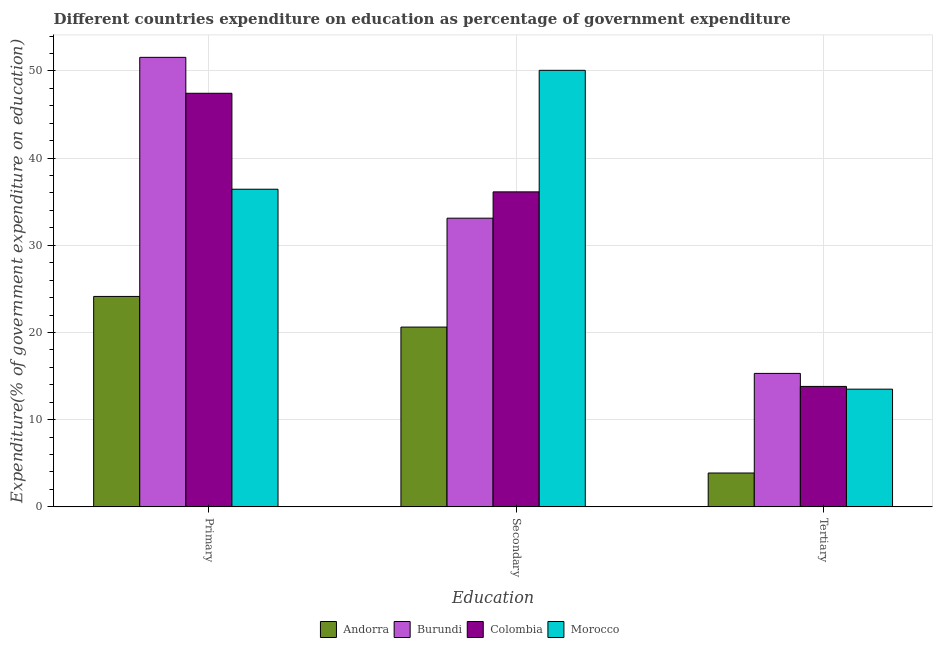How many different coloured bars are there?
Your answer should be very brief. 4. How many groups of bars are there?
Your answer should be very brief. 3. Are the number of bars per tick equal to the number of legend labels?
Make the answer very short. Yes. What is the label of the 2nd group of bars from the left?
Make the answer very short. Secondary. What is the expenditure on secondary education in Burundi?
Your response must be concise. 33.11. Across all countries, what is the maximum expenditure on secondary education?
Offer a very short reply. 50.07. Across all countries, what is the minimum expenditure on primary education?
Offer a very short reply. 24.14. In which country was the expenditure on secondary education maximum?
Make the answer very short. Morocco. In which country was the expenditure on primary education minimum?
Ensure brevity in your answer.  Andorra. What is the total expenditure on primary education in the graph?
Your answer should be compact. 159.56. What is the difference between the expenditure on tertiary education in Andorra and that in Colombia?
Your answer should be compact. -9.93. What is the difference between the expenditure on primary education in Andorra and the expenditure on secondary education in Burundi?
Keep it short and to the point. -8.97. What is the average expenditure on secondary education per country?
Make the answer very short. 34.98. What is the difference between the expenditure on primary education and expenditure on tertiary education in Morocco?
Provide a short and direct response. 22.93. In how many countries, is the expenditure on primary education greater than 30 %?
Provide a succinct answer. 3. What is the ratio of the expenditure on primary education in Burundi to that in Colombia?
Offer a terse response. 1.09. Is the difference between the expenditure on secondary education in Andorra and Colombia greater than the difference between the expenditure on primary education in Andorra and Colombia?
Offer a very short reply. Yes. What is the difference between the highest and the second highest expenditure on primary education?
Offer a very short reply. 4.12. What is the difference between the highest and the lowest expenditure on tertiary education?
Make the answer very short. 11.43. In how many countries, is the expenditure on primary education greater than the average expenditure on primary education taken over all countries?
Keep it short and to the point. 2. What does the 1st bar from the left in Tertiary represents?
Offer a terse response. Andorra. What does the 3rd bar from the right in Tertiary represents?
Provide a short and direct response. Burundi. Is it the case that in every country, the sum of the expenditure on primary education and expenditure on secondary education is greater than the expenditure on tertiary education?
Your answer should be very brief. Yes. How many bars are there?
Provide a short and direct response. 12. Are all the bars in the graph horizontal?
Provide a short and direct response. No. What is the difference between two consecutive major ticks on the Y-axis?
Offer a terse response. 10. Are the values on the major ticks of Y-axis written in scientific E-notation?
Provide a short and direct response. No. Does the graph contain grids?
Offer a terse response. Yes. Where does the legend appear in the graph?
Your response must be concise. Bottom center. How many legend labels are there?
Ensure brevity in your answer.  4. How are the legend labels stacked?
Make the answer very short. Horizontal. What is the title of the graph?
Your answer should be very brief. Different countries expenditure on education as percentage of government expenditure. What is the label or title of the X-axis?
Your answer should be compact. Education. What is the label or title of the Y-axis?
Make the answer very short. Expenditure(% of government expenditure on education). What is the Expenditure(% of government expenditure on education) of Andorra in Primary?
Offer a very short reply. 24.14. What is the Expenditure(% of government expenditure on education) of Burundi in Primary?
Your response must be concise. 51.56. What is the Expenditure(% of government expenditure on education) of Colombia in Primary?
Keep it short and to the point. 47.44. What is the Expenditure(% of government expenditure on education) in Morocco in Primary?
Offer a terse response. 36.43. What is the Expenditure(% of government expenditure on education) of Andorra in Secondary?
Offer a terse response. 20.62. What is the Expenditure(% of government expenditure on education) of Burundi in Secondary?
Provide a succinct answer. 33.11. What is the Expenditure(% of government expenditure on education) of Colombia in Secondary?
Give a very brief answer. 36.13. What is the Expenditure(% of government expenditure on education) of Morocco in Secondary?
Provide a succinct answer. 50.07. What is the Expenditure(% of government expenditure on education) of Andorra in Tertiary?
Your answer should be very brief. 3.88. What is the Expenditure(% of government expenditure on education) in Burundi in Tertiary?
Provide a short and direct response. 15.31. What is the Expenditure(% of government expenditure on education) of Colombia in Tertiary?
Offer a terse response. 13.81. What is the Expenditure(% of government expenditure on education) of Morocco in Tertiary?
Your answer should be very brief. 13.5. Across all Education, what is the maximum Expenditure(% of government expenditure on education) of Andorra?
Offer a terse response. 24.14. Across all Education, what is the maximum Expenditure(% of government expenditure on education) in Burundi?
Offer a very short reply. 51.56. Across all Education, what is the maximum Expenditure(% of government expenditure on education) of Colombia?
Keep it short and to the point. 47.44. Across all Education, what is the maximum Expenditure(% of government expenditure on education) in Morocco?
Your answer should be very brief. 50.07. Across all Education, what is the minimum Expenditure(% of government expenditure on education) of Andorra?
Your answer should be compact. 3.88. Across all Education, what is the minimum Expenditure(% of government expenditure on education) of Burundi?
Ensure brevity in your answer.  15.31. Across all Education, what is the minimum Expenditure(% of government expenditure on education) of Colombia?
Ensure brevity in your answer.  13.81. Across all Education, what is the minimum Expenditure(% of government expenditure on education) in Morocco?
Provide a short and direct response. 13.5. What is the total Expenditure(% of government expenditure on education) in Andorra in the graph?
Your answer should be compact. 48.64. What is the total Expenditure(% of government expenditure on education) of Burundi in the graph?
Keep it short and to the point. 99.97. What is the total Expenditure(% of government expenditure on education) of Colombia in the graph?
Your answer should be compact. 97.38. What is the total Expenditure(% of government expenditure on education) of Morocco in the graph?
Offer a very short reply. 100. What is the difference between the Expenditure(% of government expenditure on education) of Andorra in Primary and that in Secondary?
Your answer should be compact. 3.52. What is the difference between the Expenditure(% of government expenditure on education) of Burundi in Primary and that in Secondary?
Your response must be concise. 18.45. What is the difference between the Expenditure(% of government expenditure on education) in Colombia in Primary and that in Secondary?
Keep it short and to the point. 11.31. What is the difference between the Expenditure(% of government expenditure on education) of Morocco in Primary and that in Secondary?
Provide a short and direct response. -13.64. What is the difference between the Expenditure(% of government expenditure on education) of Andorra in Primary and that in Tertiary?
Give a very brief answer. 20.25. What is the difference between the Expenditure(% of government expenditure on education) of Burundi in Primary and that in Tertiary?
Make the answer very short. 36.25. What is the difference between the Expenditure(% of government expenditure on education) in Colombia in Primary and that in Tertiary?
Provide a short and direct response. 33.62. What is the difference between the Expenditure(% of government expenditure on education) in Morocco in Primary and that in Tertiary?
Ensure brevity in your answer.  22.93. What is the difference between the Expenditure(% of government expenditure on education) in Andorra in Secondary and that in Tertiary?
Your response must be concise. 16.74. What is the difference between the Expenditure(% of government expenditure on education) in Burundi in Secondary and that in Tertiary?
Your response must be concise. 17.8. What is the difference between the Expenditure(% of government expenditure on education) in Colombia in Secondary and that in Tertiary?
Provide a succinct answer. 22.31. What is the difference between the Expenditure(% of government expenditure on education) of Morocco in Secondary and that in Tertiary?
Offer a very short reply. 36.57. What is the difference between the Expenditure(% of government expenditure on education) of Andorra in Primary and the Expenditure(% of government expenditure on education) of Burundi in Secondary?
Offer a terse response. -8.97. What is the difference between the Expenditure(% of government expenditure on education) of Andorra in Primary and the Expenditure(% of government expenditure on education) of Colombia in Secondary?
Provide a succinct answer. -11.99. What is the difference between the Expenditure(% of government expenditure on education) in Andorra in Primary and the Expenditure(% of government expenditure on education) in Morocco in Secondary?
Provide a short and direct response. -25.93. What is the difference between the Expenditure(% of government expenditure on education) of Burundi in Primary and the Expenditure(% of government expenditure on education) of Colombia in Secondary?
Provide a succinct answer. 15.43. What is the difference between the Expenditure(% of government expenditure on education) of Burundi in Primary and the Expenditure(% of government expenditure on education) of Morocco in Secondary?
Your answer should be very brief. 1.49. What is the difference between the Expenditure(% of government expenditure on education) in Colombia in Primary and the Expenditure(% of government expenditure on education) in Morocco in Secondary?
Your answer should be compact. -2.63. What is the difference between the Expenditure(% of government expenditure on education) of Andorra in Primary and the Expenditure(% of government expenditure on education) of Burundi in Tertiary?
Ensure brevity in your answer.  8.83. What is the difference between the Expenditure(% of government expenditure on education) in Andorra in Primary and the Expenditure(% of government expenditure on education) in Colombia in Tertiary?
Provide a succinct answer. 10.32. What is the difference between the Expenditure(% of government expenditure on education) of Andorra in Primary and the Expenditure(% of government expenditure on education) of Morocco in Tertiary?
Make the answer very short. 10.64. What is the difference between the Expenditure(% of government expenditure on education) of Burundi in Primary and the Expenditure(% of government expenditure on education) of Colombia in Tertiary?
Offer a very short reply. 37.74. What is the difference between the Expenditure(% of government expenditure on education) in Burundi in Primary and the Expenditure(% of government expenditure on education) in Morocco in Tertiary?
Your answer should be compact. 38.06. What is the difference between the Expenditure(% of government expenditure on education) of Colombia in Primary and the Expenditure(% of government expenditure on education) of Morocco in Tertiary?
Offer a very short reply. 33.94. What is the difference between the Expenditure(% of government expenditure on education) in Andorra in Secondary and the Expenditure(% of government expenditure on education) in Burundi in Tertiary?
Keep it short and to the point. 5.31. What is the difference between the Expenditure(% of government expenditure on education) of Andorra in Secondary and the Expenditure(% of government expenditure on education) of Colombia in Tertiary?
Your answer should be very brief. 6.8. What is the difference between the Expenditure(% of government expenditure on education) of Andorra in Secondary and the Expenditure(% of government expenditure on education) of Morocco in Tertiary?
Keep it short and to the point. 7.12. What is the difference between the Expenditure(% of government expenditure on education) of Burundi in Secondary and the Expenditure(% of government expenditure on education) of Colombia in Tertiary?
Ensure brevity in your answer.  19.3. What is the difference between the Expenditure(% of government expenditure on education) in Burundi in Secondary and the Expenditure(% of government expenditure on education) in Morocco in Tertiary?
Your answer should be very brief. 19.61. What is the difference between the Expenditure(% of government expenditure on education) of Colombia in Secondary and the Expenditure(% of government expenditure on education) of Morocco in Tertiary?
Offer a terse response. 22.63. What is the average Expenditure(% of government expenditure on education) of Andorra per Education?
Your response must be concise. 16.21. What is the average Expenditure(% of government expenditure on education) of Burundi per Education?
Give a very brief answer. 33.32. What is the average Expenditure(% of government expenditure on education) in Colombia per Education?
Your answer should be compact. 32.46. What is the average Expenditure(% of government expenditure on education) of Morocco per Education?
Your answer should be compact. 33.33. What is the difference between the Expenditure(% of government expenditure on education) of Andorra and Expenditure(% of government expenditure on education) of Burundi in Primary?
Provide a succinct answer. -27.42. What is the difference between the Expenditure(% of government expenditure on education) of Andorra and Expenditure(% of government expenditure on education) of Colombia in Primary?
Ensure brevity in your answer.  -23.3. What is the difference between the Expenditure(% of government expenditure on education) in Andorra and Expenditure(% of government expenditure on education) in Morocco in Primary?
Offer a terse response. -12.3. What is the difference between the Expenditure(% of government expenditure on education) in Burundi and Expenditure(% of government expenditure on education) in Colombia in Primary?
Keep it short and to the point. 4.12. What is the difference between the Expenditure(% of government expenditure on education) of Burundi and Expenditure(% of government expenditure on education) of Morocco in Primary?
Offer a terse response. 15.13. What is the difference between the Expenditure(% of government expenditure on education) of Colombia and Expenditure(% of government expenditure on education) of Morocco in Primary?
Offer a very short reply. 11.01. What is the difference between the Expenditure(% of government expenditure on education) in Andorra and Expenditure(% of government expenditure on education) in Burundi in Secondary?
Give a very brief answer. -12.49. What is the difference between the Expenditure(% of government expenditure on education) in Andorra and Expenditure(% of government expenditure on education) in Colombia in Secondary?
Make the answer very short. -15.51. What is the difference between the Expenditure(% of government expenditure on education) in Andorra and Expenditure(% of government expenditure on education) in Morocco in Secondary?
Your answer should be compact. -29.45. What is the difference between the Expenditure(% of government expenditure on education) in Burundi and Expenditure(% of government expenditure on education) in Colombia in Secondary?
Your response must be concise. -3.02. What is the difference between the Expenditure(% of government expenditure on education) in Burundi and Expenditure(% of government expenditure on education) in Morocco in Secondary?
Keep it short and to the point. -16.96. What is the difference between the Expenditure(% of government expenditure on education) of Colombia and Expenditure(% of government expenditure on education) of Morocco in Secondary?
Offer a very short reply. -13.94. What is the difference between the Expenditure(% of government expenditure on education) of Andorra and Expenditure(% of government expenditure on education) of Burundi in Tertiary?
Offer a terse response. -11.43. What is the difference between the Expenditure(% of government expenditure on education) of Andorra and Expenditure(% of government expenditure on education) of Colombia in Tertiary?
Your answer should be very brief. -9.93. What is the difference between the Expenditure(% of government expenditure on education) in Andorra and Expenditure(% of government expenditure on education) in Morocco in Tertiary?
Give a very brief answer. -9.62. What is the difference between the Expenditure(% of government expenditure on education) of Burundi and Expenditure(% of government expenditure on education) of Colombia in Tertiary?
Offer a very short reply. 1.49. What is the difference between the Expenditure(% of government expenditure on education) of Burundi and Expenditure(% of government expenditure on education) of Morocco in Tertiary?
Give a very brief answer. 1.81. What is the difference between the Expenditure(% of government expenditure on education) of Colombia and Expenditure(% of government expenditure on education) of Morocco in Tertiary?
Offer a very short reply. 0.31. What is the ratio of the Expenditure(% of government expenditure on education) of Andorra in Primary to that in Secondary?
Give a very brief answer. 1.17. What is the ratio of the Expenditure(% of government expenditure on education) in Burundi in Primary to that in Secondary?
Make the answer very short. 1.56. What is the ratio of the Expenditure(% of government expenditure on education) in Colombia in Primary to that in Secondary?
Offer a terse response. 1.31. What is the ratio of the Expenditure(% of government expenditure on education) of Morocco in Primary to that in Secondary?
Your answer should be compact. 0.73. What is the ratio of the Expenditure(% of government expenditure on education) in Andorra in Primary to that in Tertiary?
Keep it short and to the point. 6.22. What is the ratio of the Expenditure(% of government expenditure on education) of Burundi in Primary to that in Tertiary?
Your response must be concise. 3.37. What is the ratio of the Expenditure(% of government expenditure on education) of Colombia in Primary to that in Tertiary?
Make the answer very short. 3.43. What is the ratio of the Expenditure(% of government expenditure on education) in Morocco in Primary to that in Tertiary?
Make the answer very short. 2.7. What is the ratio of the Expenditure(% of government expenditure on education) in Andorra in Secondary to that in Tertiary?
Ensure brevity in your answer.  5.31. What is the ratio of the Expenditure(% of government expenditure on education) in Burundi in Secondary to that in Tertiary?
Your response must be concise. 2.16. What is the ratio of the Expenditure(% of government expenditure on education) in Colombia in Secondary to that in Tertiary?
Offer a terse response. 2.62. What is the ratio of the Expenditure(% of government expenditure on education) in Morocco in Secondary to that in Tertiary?
Give a very brief answer. 3.71. What is the difference between the highest and the second highest Expenditure(% of government expenditure on education) of Andorra?
Ensure brevity in your answer.  3.52. What is the difference between the highest and the second highest Expenditure(% of government expenditure on education) of Burundi?
Your response must be concise. 18.45. What is the difference between the highest and the second highest Expenditure(% of government expenditure on education) in Colombia?
Ensure brevity in your answer.  11.31. What is the difference between the highest and the second highest Expenditure(% of government expenditure on education) of Morocco?
Your answer should be compact. 13.64. What is the difference between the highest and the lowest Expenditure(% of government expenditure on education) of Andorra?
Provide a succinct answer. 20.25. What is the difference between the highest and the lowest Expenditure(% of government expenditure on education) in Burundi?
Offer a terse response. 36.25. What is the difference between the highest and the lowest Expenditure(% of government expenditure on education) in Colombia?
Ensure brevity in your answer.  33.62. What is the difference between the highest and the lowest Expenditure(% of government expenditure on education) of Morocco?
Your answer should be very brief. 36.57. 